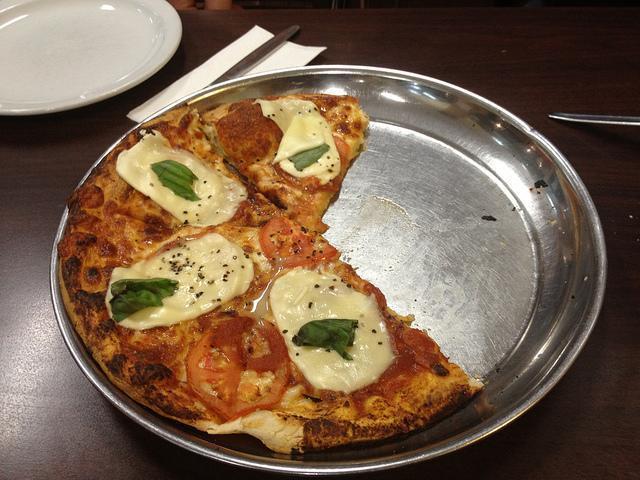How many slices are left?
Give a very brief answer. 4. 